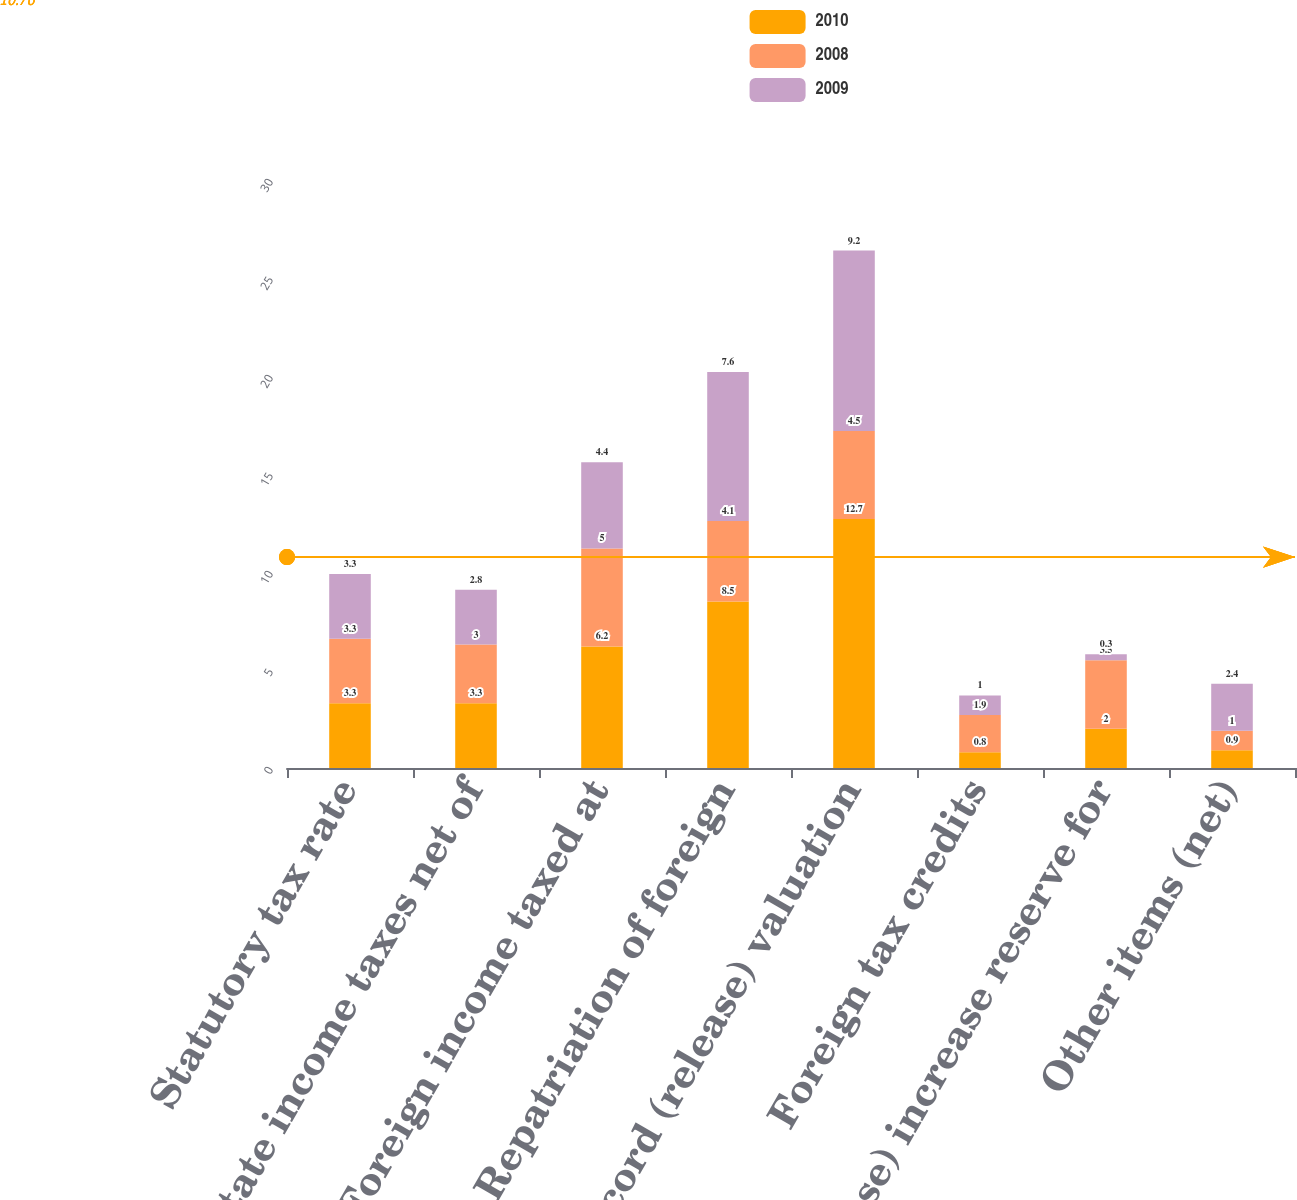<chart> <loc_0><loc_0><loc_500><loc_500><stacked_bar_chart><ecel><fcel>Statutory tax rate<fcel>State income taxes net of<fcel>Foreign income taxed at<fcel>Repatriation of foreign<fcel>Record (release) valuation<fcel>Foreign tax credits<fcel>(Release) increase reserve for<fcel>Other items (net)<nl><fcel>2010<fcel>3.3<fcel>3.3<fcel>6.2<fcel>8.5<fcel>12.7<fcel>0.8<fcel>2<fcel>0.9<nl><fcel>2008<fcel>3.3<fcel>3<fcel>5<fcel>4.1<fcel>4.5<fcel>1.9<fcel>3.5<fcel>1<nl><fcel>2009<fcel>3.3<fcel>2.8<fcel>4.4<fcel>7.6<fcel>9.2<fcel>1<fcel>0.3<fcel>2.4<nl></chart> 